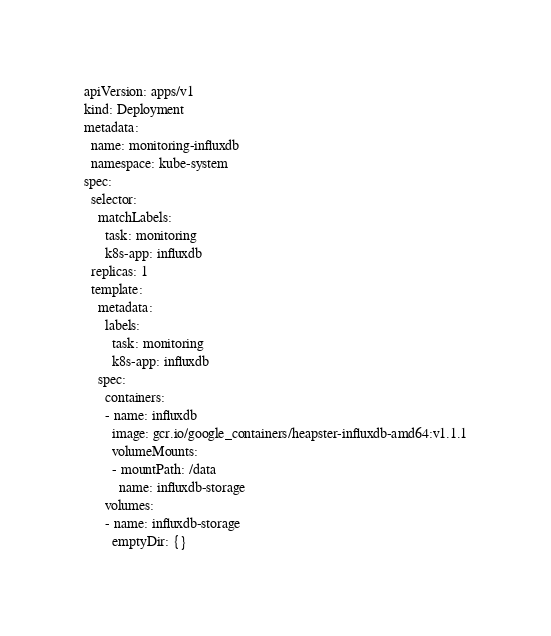<code> <loc_0><loc_0><loc_500><loc_500><_YAML_>apiVersion: apps/v1
kind: Deployment
metadata:
  name: monitoring-influxdb
  namespace: kube-system
spec:
  selector:
    matchLabels:
      task: monitoring
      k8s-app: influxdb
  replicas: 1
  template:
    metadata:
      labels:
        task: monitoring
        k8s-app: influxdb
    spec:
      containers:
      - name: influxdb
        image: gcr.io/google_containers/heapster-influxdb-amd64:v1.1.1
        volumeMounts:
        - mountPath: /data
          name: influxdb-storage
      volumes:
      - name: influxdb-storage
        emptyDir: {}
</code> 